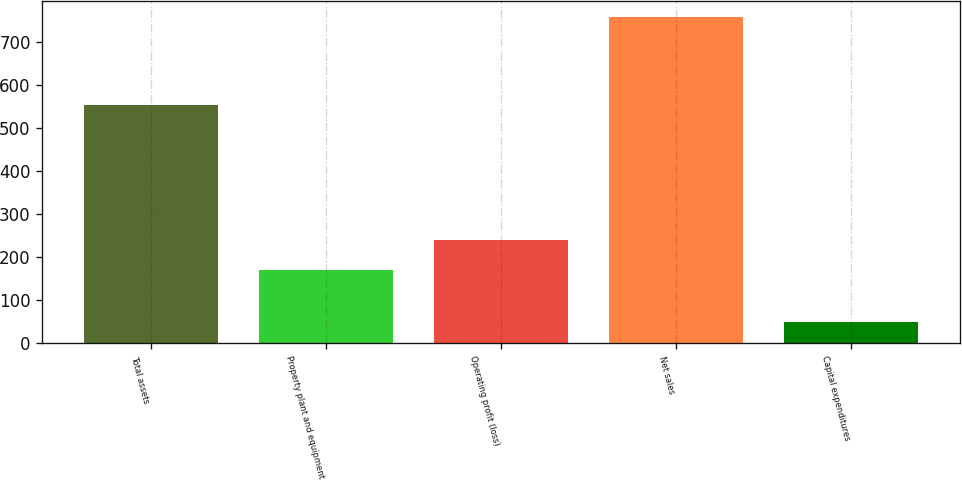<chart> <loc_0><loc_0><loc_500><loc_500><bar_chart><fcel>Total assets<fcel>Property plant and equipment<fcel>Operating profit (loss)<fcel>Net sales<fcel>Capital expenditures<nl><fcel>554<fcel>170<fcel>240.8<fcel>758<fcel>50<nl></chart> 